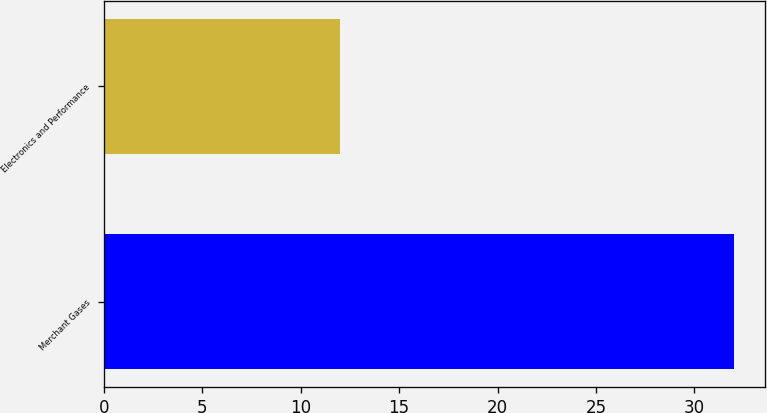<chart> <loc_0><loc_0><loc_500><loc_500><bar_chart><fcel>Merchant Gases<fcel>Electronics and Performance<nl><fcel>32<fcel>12<nl></chart> 